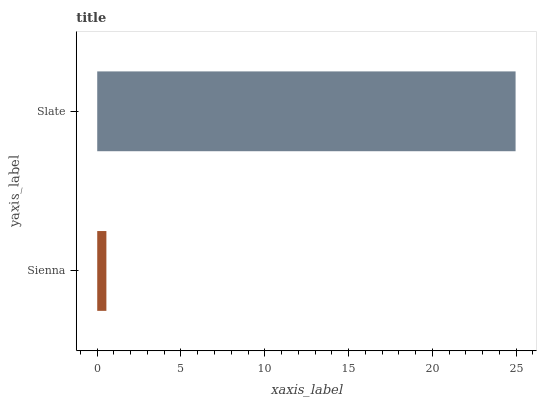Is Sienna the minimum?
Answer yes or no. Yes. Is Slate the maximum?
Answer yes or no. Yes. Is Slate the minimum?
Answer yes or no. No. Is Slate greater than Sienna?
Answer yes or no. Yes. Is Sienna less than Slate?
Answer yes or no. Yes. Is Sienna greater than Slate?
Answer yes or no. No. Is Slate less than Sienna?
Answer yes or no. No. Is Slate the high median?
Answer yes or no. Yes. Is Sienna the low median?
Answer yes or no. Yes. Is Sienna the high median?
Answer yes or no. No. Is Slate the low median?
Answer yes or no. No. 